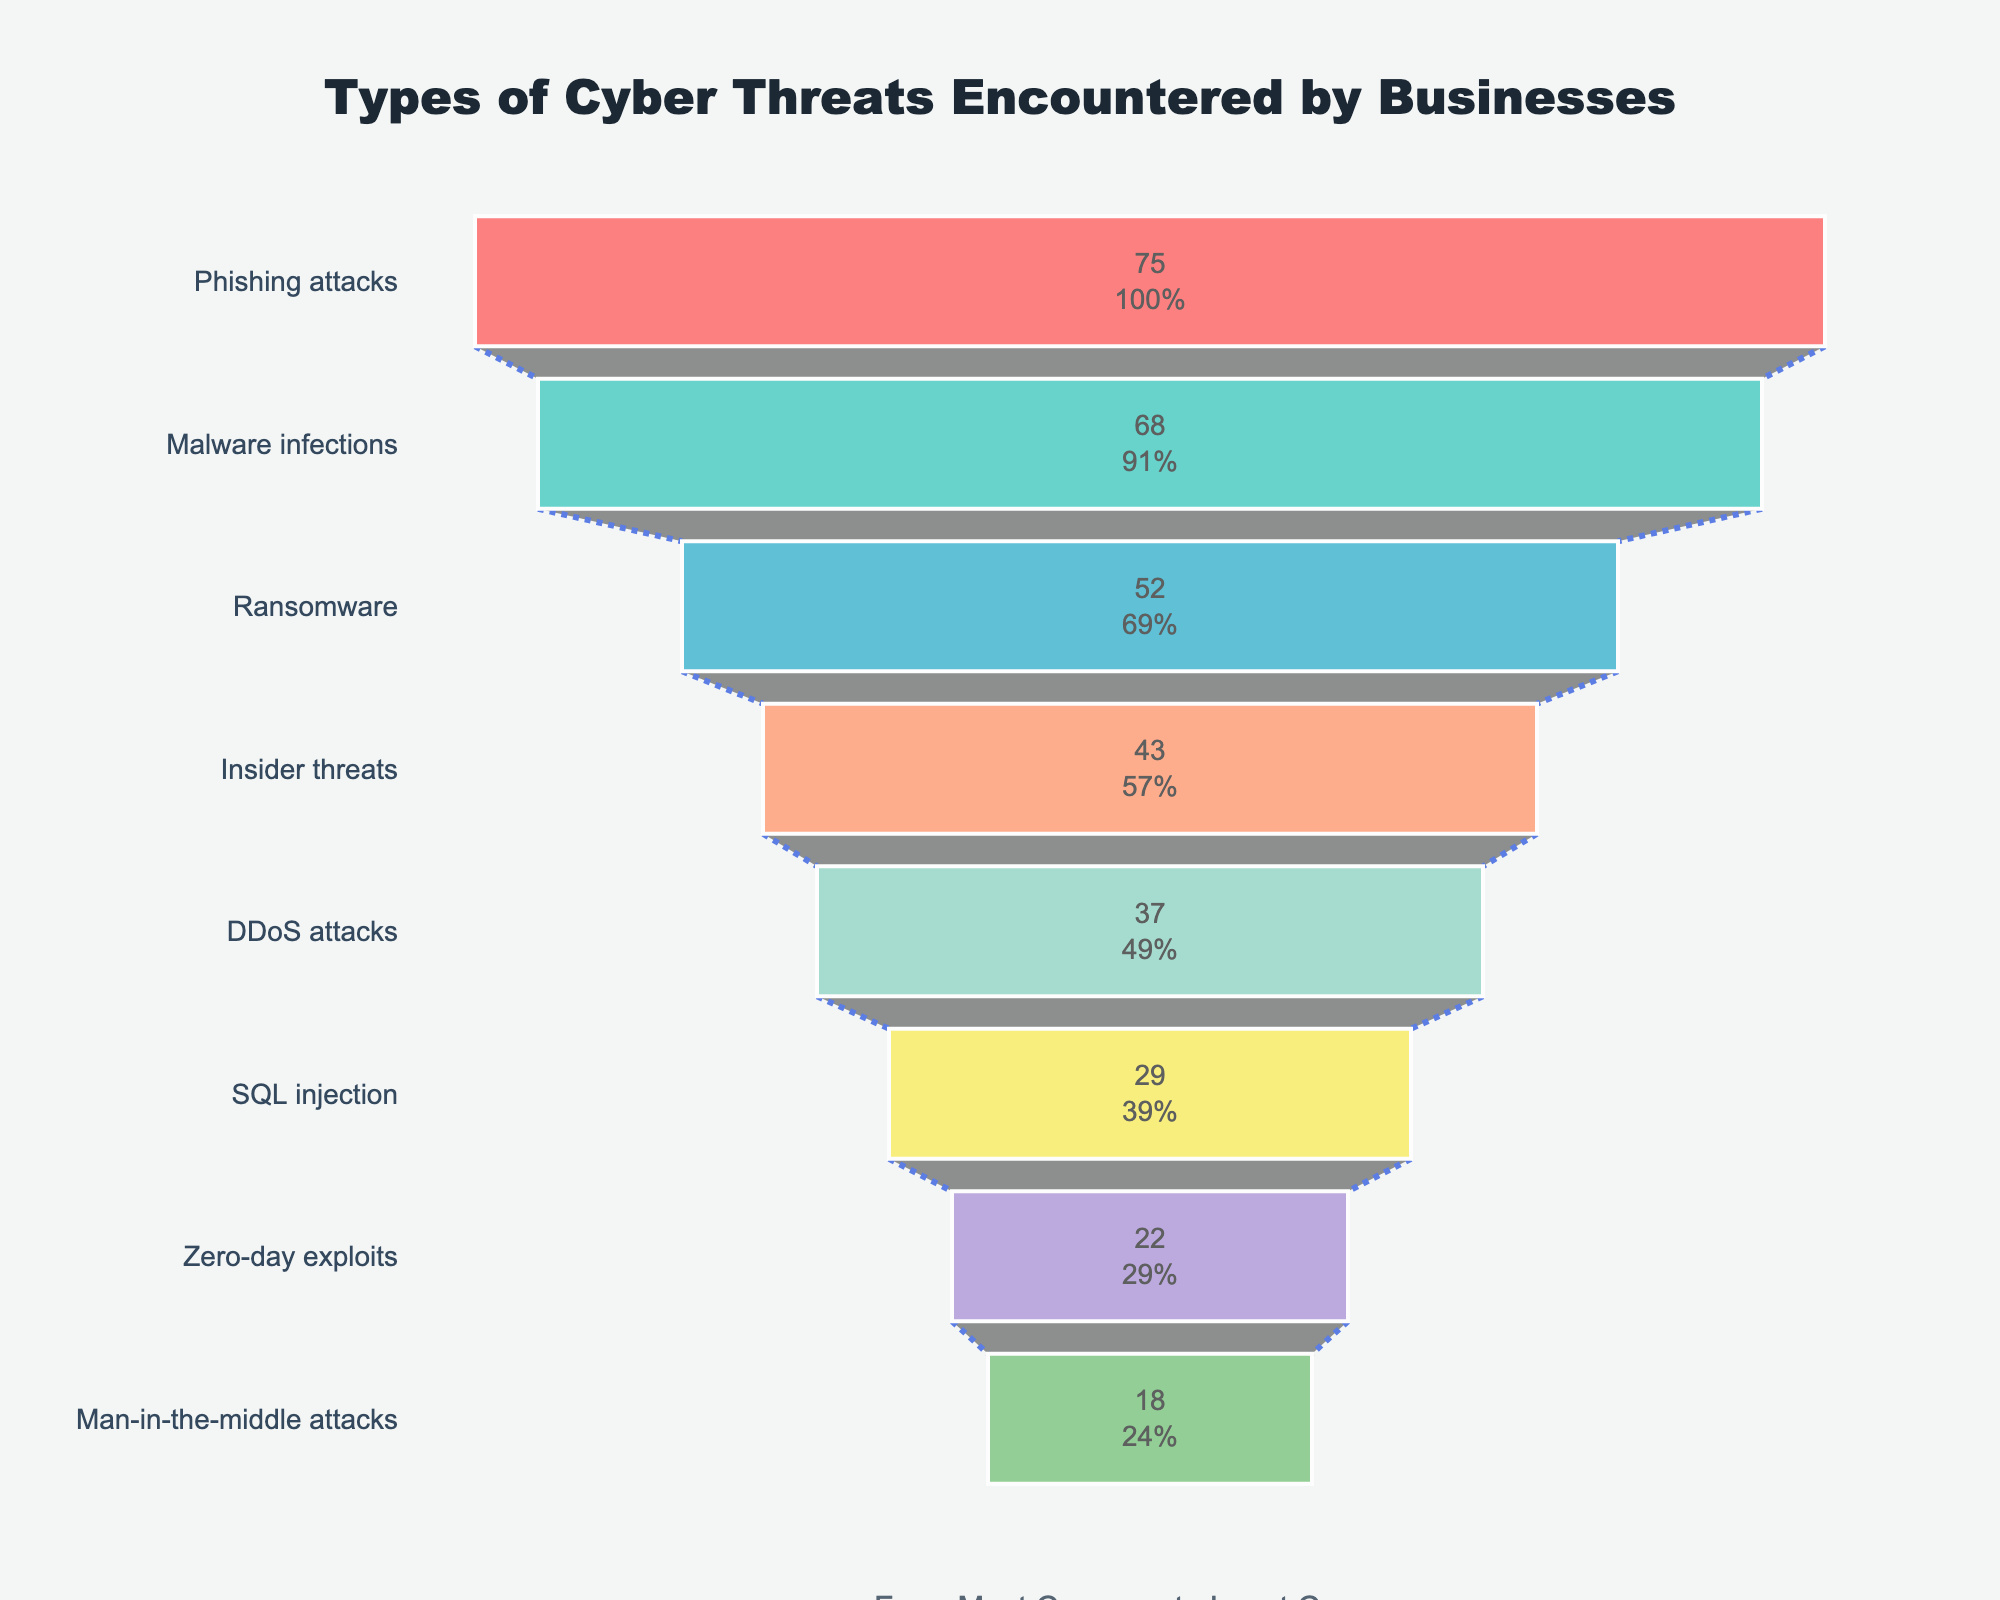what is the title of the figure? The title of the figure is located at the top and centered; it reads, "Types of Cyber Threats Encountered by Businesses".
Answer: Types of Cyber Threats Encountered by Businesses What type of cyber threat has the highest frequency? The highest frequency value is positioned at the top of the funnel and is associated with "Phishing attacks" with a frequency of 75.
Answer: Phishing attacks How many types of cyber threats are documented in the figure? There are 8 different cyber threats listed, counted by the segments of the funnel chart.
Answer: 8 What percentage of the total does "Ransomware" represent at the initial stage? "Ransomware" is represented within the funnel chart along with the percentage value inside its section. Specifically, "Ransomware" shows 52 which is 26% of the entries as the initial stage.
Answer: 26% Which type of cyber threat is encountered more frequently: "Insider threats" or "DDoS attacks"? "Insider threats" have a frequency of 43 while "DDoS attacks" have a frequency of 37, making "Insider threats" more frequent.
Answer: Insider threats What is the difference in frequency between "Malware infections" and "Zero-day exploits"? "Malware infections" have a frequency of 68 while "Zero-day exploits" have a frequency of 22. The difference can be calculated as 68 - 22 = 46.
Answer: 46 What is the average frequency of the three most common cyber threats? The three most common cyber threats are "Phishing attacks" (75), "Malware infections" (68), and "Ransomware" (52). The average frequency is calculated as (75 + 68 + 52)/3 = 65.
Answer: 65 Which cyber threat has the least frequency, and what is its value? The lowest frequency is found at the bottom of the funnel and belongs to "Man-in-the-middle attacks" with a value of 18.
Answer: Man-in-the-middle attacks, 18 How much higher is the frequency of "Phishing attacks" compared to "SQL injection"? "Phishing attacks" have a frequency of 75, and "SQL injection" has a frequency of 29. The difference is 75 - 29 = 46.
Answer: 46 Is the frequency of "Malware infections" greater than twice the frequency of "Man-in-the-middle attacks"? "Malware infections" have a frequency of 68. Twice the frequency of "Man-in-the-middle attacks" is 2 * 18 = 36. Since 68 > 36, it's true.
Answer: Yes 